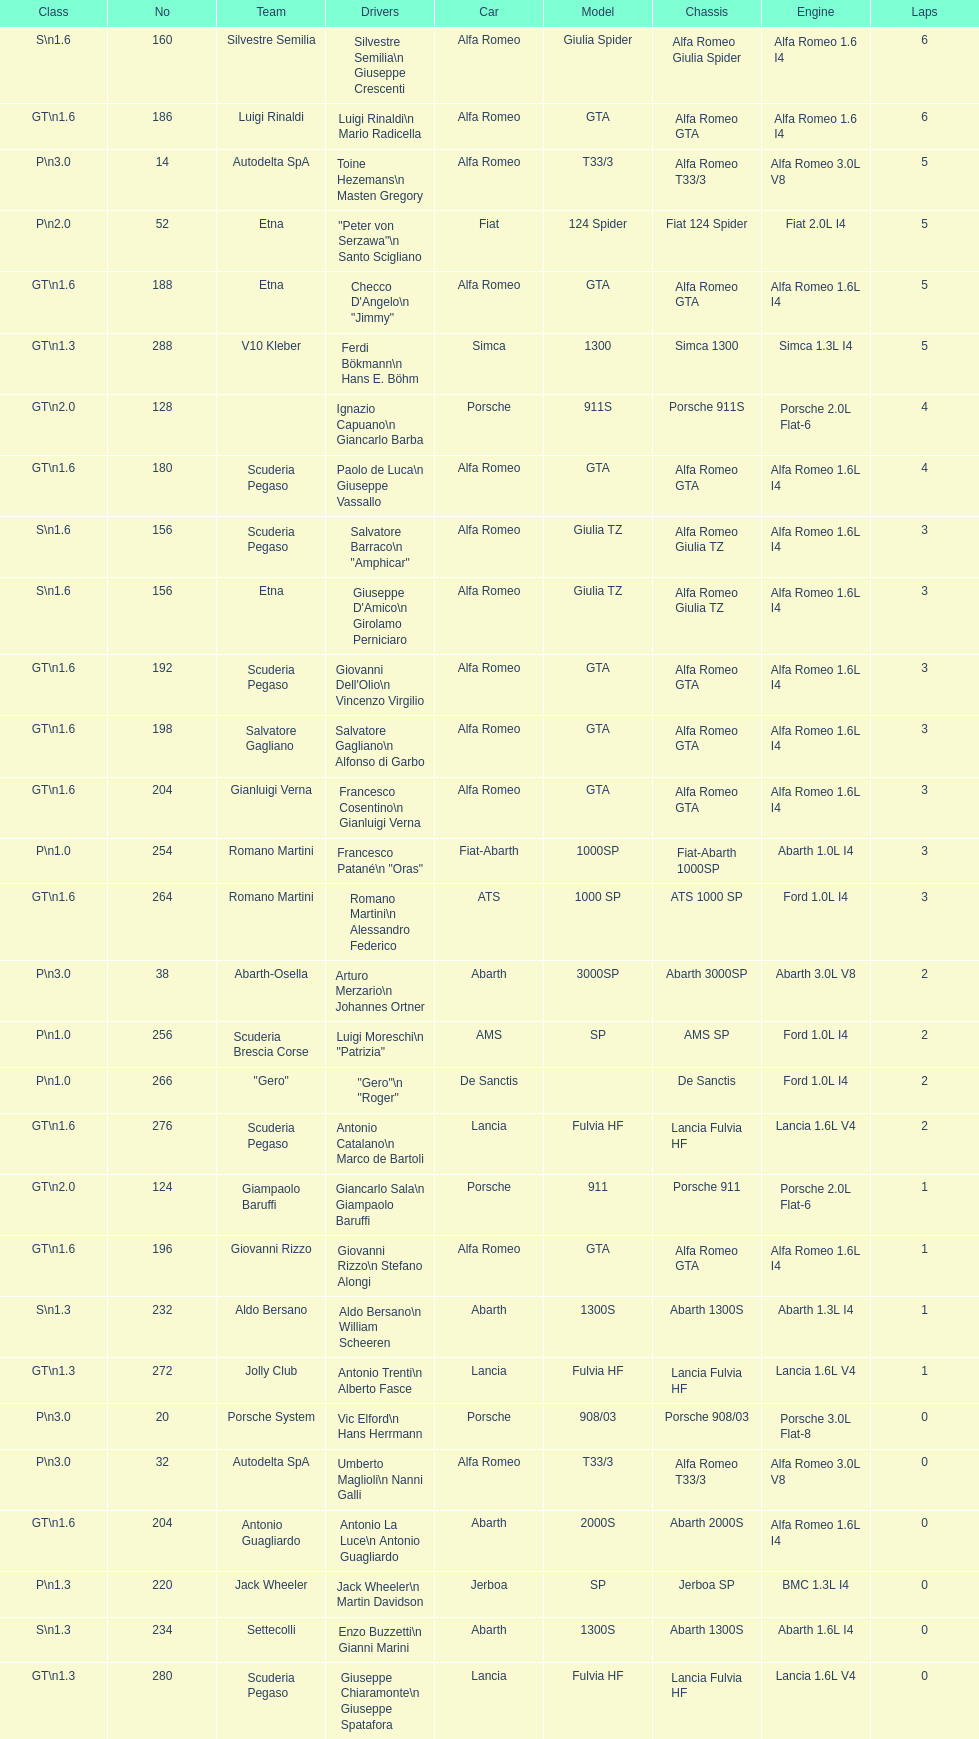How many teams failed to finish the race after 2 laps? 4. 